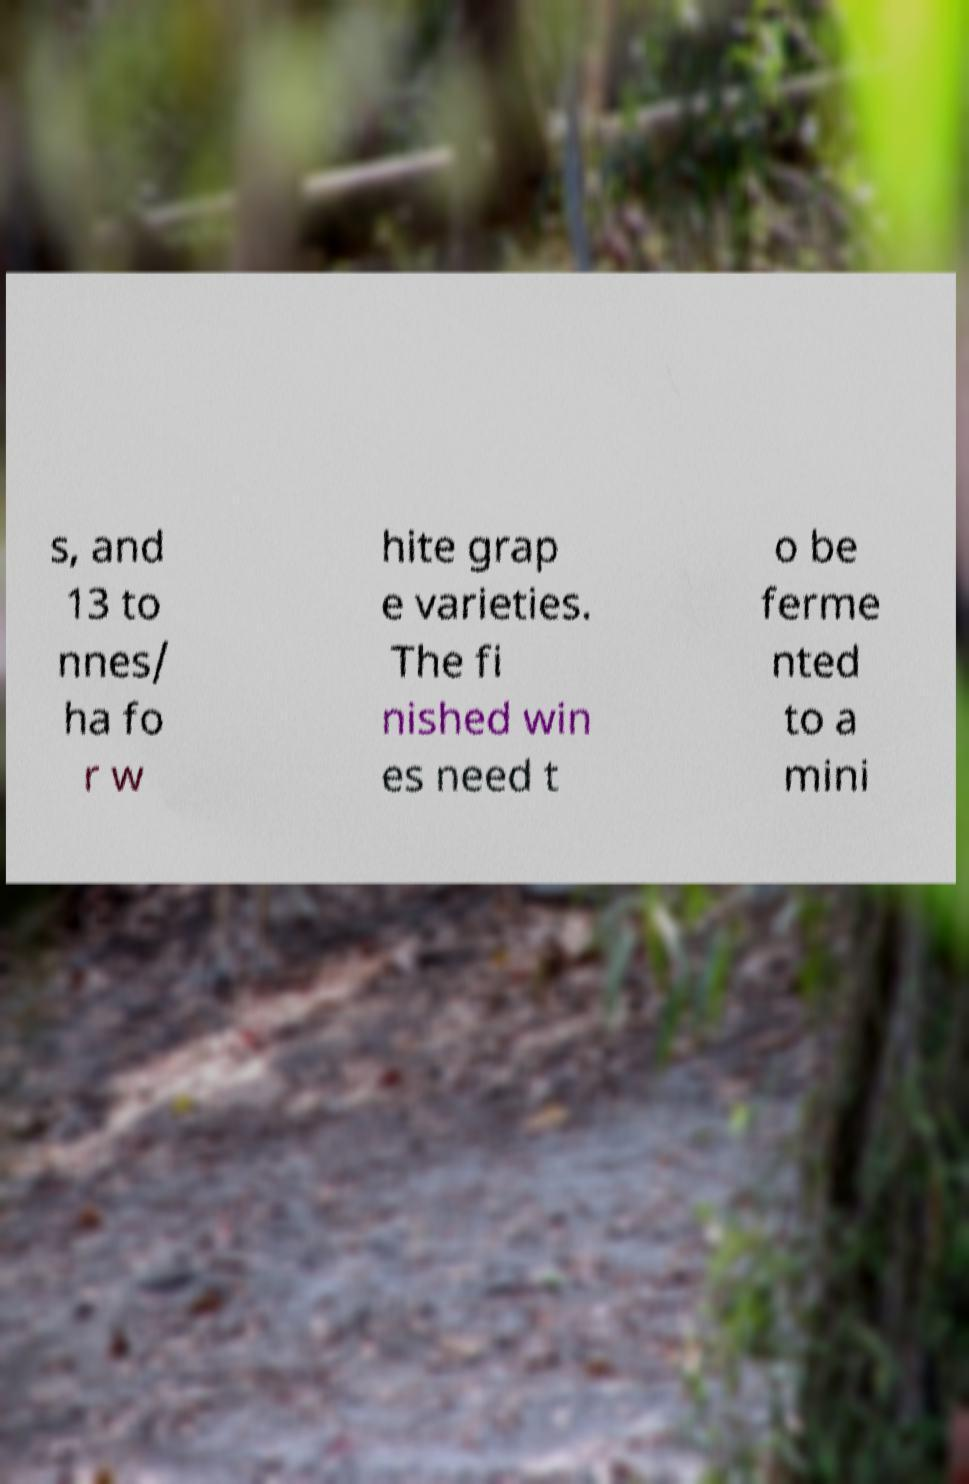I need the written content from this picture converted into text. Can you do that? s, and 13 to nnes/ ha fo r w hite grap e varieties. The fi nished win es need t o be ferme nted to a mini 